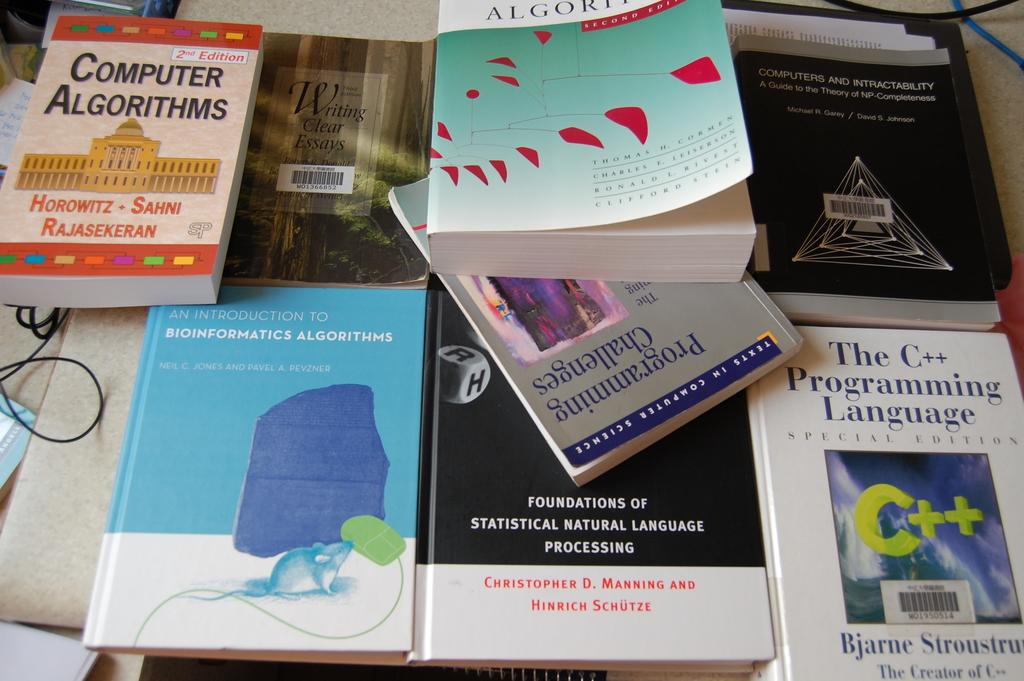Who wrote the book titled foundations of statistical natural language programming?
Ensure brevity in your answer.  Christopher d. manning and hinrich schutze. What is the bottom righthand book title?
Your response must be concise. The c++ programming language. 